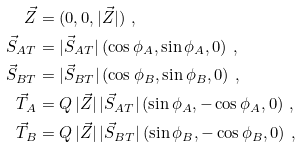Convert formula to latex. <formula><loc_0><loc_0><loc_500><loc_500>\vec { Z } & = ( 0 , 0 , | \vec { Z } | ) \ , \\ \vec { S } _ { A T } & = | \vec { S } _ { A T } | \, ( \cos \phi _ { A } , \sin \phi _ { A } , 0 ) \ , \\ \vec { S } _ { B T } & = | \vec { S } _ { B T } | \, ( \cos \phi _ { B } , \sin \phi _ { B } , 0 ) \ , \\ \vec { T } _ { A } & = Q \, | \vec { Z } | \, | \vec { S } _ { A T } | \, ( \sin \phi _ { A } , - \cos \phi _ { A } , 0 ) \ , \\ \vec { T } _ { B } & = Q \, | \vec { Z } | \, | \vec { S } _ { B T } | \, ( \sin \phi _ { B } , - \cos \phi _ { B } , 0 ) \ ,</formula> 